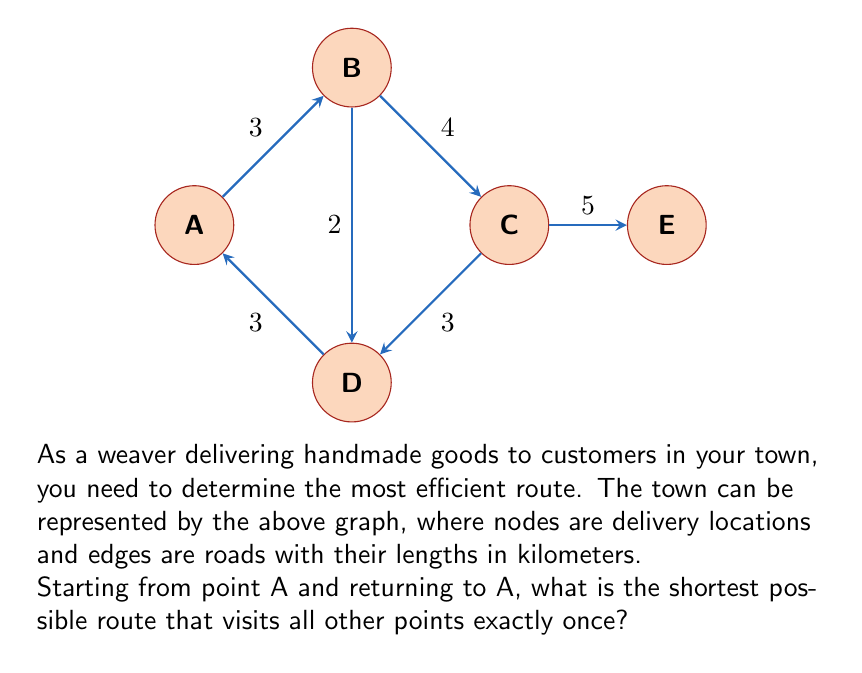Can you solve this math problem? To solve this problem, we need to find the Hamiltonian cycle with the minimum total weight in the given graph. This is known as the Traveling Salesman Problem (TSP).

Given the small size of the graph, we can solve this by enumerating all possible Hamiltonian cycles and comparing their total lengths:

1) Possible Hamiltonian cycles starting and ending at A:
   A-B-C-D-E-A
   A-B-C-E-D-A
   A-B-D-C-E-A
   A-D-B-C-E-A

2) Calculate the length of each cycle:

   A-B-C-D-E-A: 3 + 4 + 3 + 5 + 7 = 22 km
   A-B-C-E-D-A: 3 + 4 + 5 + 3 + 3 = 18 km
   A-B-D-C-E-A: 3 + 2 + 3 + 5 + 7 = 20 km
   A-D-B-C-E-A: 3 + 2 + 4 + 5 + 7 = 21 km

3) The shortest cycle is A-B-C-E-D-A with a total length of 18 km.

This route can be described as:
Start at A → Go to B (3 km) → Go to C (4 km) → Go to E (5 km) → Go to D (3 km) → Return to A (3 km)

The total distance traveled is:

$$ 3 + 4 + 5 + 3 + 3 = 18 \text{ km} $$

Therefore, the most efficient path for delivering woven goods to all customers and returning to the starting point is A-B-C-E-D-A, with a total distance of 18 km.
Answer: A-B-C-E-D-A, 18 km 